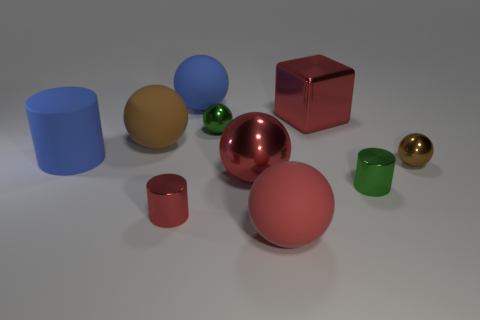There is a metal cylinder that is on the right side of the large red matte thing; is its size the same as the red metallic ball that is behind the red matte object?
Make the answer very short. No. What number of small cylinders are the same color as the large cube?
Your response must be concise. 1. What material is the big thing that is the same color as the big matte cylinder?
Your answer should be very brief. Rubber. Is the number of big things on the left side of the red cylinder greater than the number of big red balls?
Your response must be concise. No. Does the brown rubber thing have the same shape as the brown metallic thing?
Offer a terse response. Yes. What number of large brown objects have the same material as the small brown thing?
Your answer should be compact. 0. What size is the green metal thing that is the same shape as the red matte object?
Give a very brief answer. Small. Is the size of the green cylinder the same as the green sphere?
Provide a succinct answer. Yes. The tiny metal thing that is right of the cylinder right of the tiny green metallic thing that is behind the blue rubber cylinder is what shape?
Give a very brief answer. Sphere. There is another small thing that is the same shape as the small brown object; what color is it?
Provide a succinct answer. Green. 